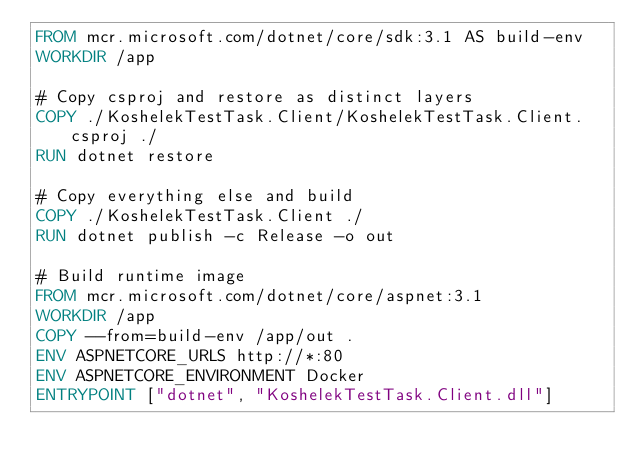<code> <loc_0><loc_0><loc_500><loc_500><_Dockerfile_>FROM mcr.microsoft.com/dotnet/core/sdk:3.1 AS build-env
WORKDIR /app

# Copy csproj and restore as distinct layers
COPY ./KoshelekTestTask.Client/KoshelekTestTask.Client.csproj ./
RUN dotnet restore

# Copy everything else and build
COPY ./KoshelekTestTask.Client ./
RUN dotnet publish -c Release -o out

# Build runtime image
FROM mcr.microsoft.com/dotnet/core/aspnet:3.1
WORKDIR /app
COPY --from=build-env /app/out .
ENV ASPNETCORE_URLS http://*:80
ENV ASPNETCORE_ENVIRONMENT Docker
ENTRYPOINT ["dotnet", "KoshelekTestTask.Client.dll"]</code> 